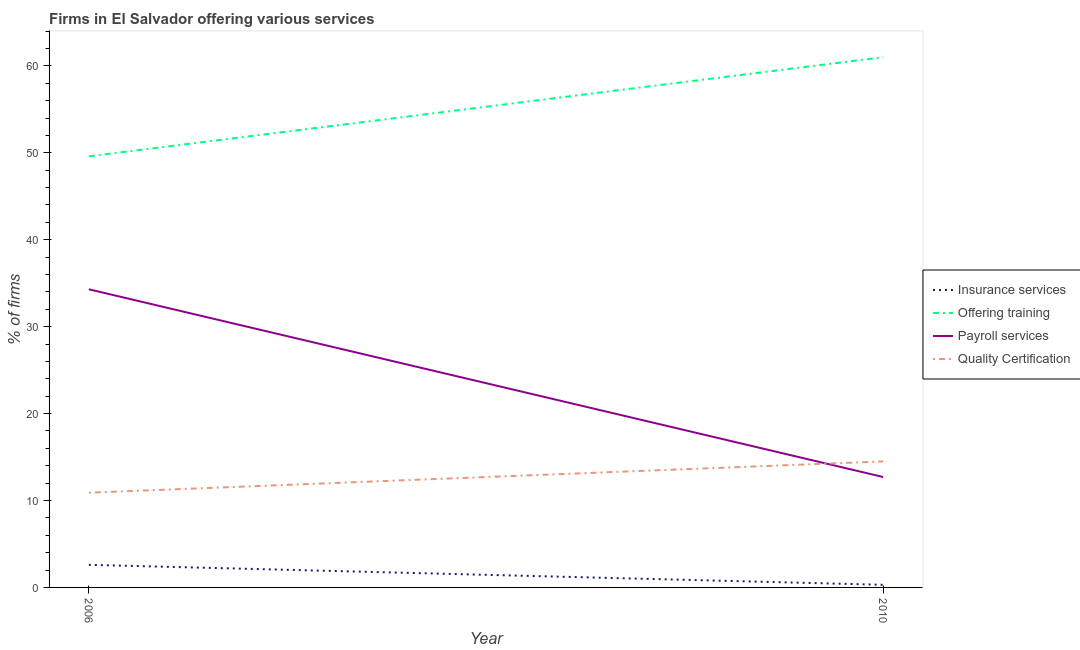How many different coloured lines are there?
Your answer should be very brief. 4. What is the percentage of firms offering insurance services in 2010?
Keep it short and to the point. 0.3. Across all years, what is the minimum percentage of firms offering insurance services?
Make the answer very short. 0.3. In which year was the percentage of firms offering quality certification minimum?
Your answer should be very brief. 2006. What is the total percentage of firms offering training in the graph?
Offer a very short reply. 110.6. What is the difference between the percentage of firms offering quality certification in 2006 and that in 2010?
Ensure brevity in your answer.  -3.6. What is the difference between the percentage of firms offering training in 2006 and the percentage of firms offering quality certification in 2010?
Your answer should be compact. 35.1. What is the average percentage of firms offering quality certification per year?
Give a very brief answer. 12.7. In the year 2006, what is the difference between the percentage of firms offering payroll services and percentage of firms offering training?
Your answer should be very brief. -15.3. In how many years, is the percentage of firms offering training greater than 12 %?
Make the answer very short. 2. What is the ratio of the percentage of firms offering quality certification in 2006 to that in 2010?
Offer a terse response. 0.75. In how many years, is the percentage of firms offering insurance services greater than the average percentage of firms offering insurance services taken over all years?
Your response must be concise. 1. Is it the case that in every year, the sum of the percentage of firms offering insurance services and percentage of firms offering training is greater than the percentage of firms offering payroll services?
Provide a short and direct response. Yes. Is the percentage of firms offering payroll services strictly greater than the percentage of firms offering insurance services over the years?
Your answer should be compact. Yes. How many lines are there?
Your answer should be compact. 4. Are the values on the major ticks of Y-axis written in scientific E-notation?
Ensure brevity in your answer.  No. Where does the legend appear in the graph?
Provide a succinct answer. Center right. What is the title of the graph?
Your answer should be compact. Firms in El Salvador offering various services . Does "Structural Policies" appear as one of the legend labels in the graph?
Your response must be concise. No. What is the label or title of the Y-axis?
Offer a very short reply. % of firms. What is the % of firms of Insurance services in 2006?
Your response must be concise. 2.6. What is the % of firms of Offering training in 2006?
Make the answer very short. 49.6. What is the % of firms of Payroll services in 2006?
Your response must be concise. 34.3. What is the % of firms in Quality Certification in 2006?
Keep it short and to the point. 10.9. What is the % of firms of Payroll services in 2010?
Your response must be concise. 12.7. What is the % of firms in Quality Certification in 2010?
Ensure brevity in your answer.  14.5. Across all years, what is the maximum % of firms in Offering training?
Offer a very short reply. 61. Across all years, what is the maximum % of firms in Payroll services?
Ensure brevity in your answer.  34.3. Across all years, what is the minimum % of firms in Insurance services?
Your answer should be very brief. 0.3. Across all years, what is the minimum % of firms of Offering training?
Keep it short and to the point. 49.6. Across all years, what is the minimum % of firms of Payroll services?
Your response must be concise. 12.7. Across all years, what is the minimum % of firms of Quality Certification?
Give a very brief answer. 10.9. What is the total % of firms of Insurance services in the graph?
Give a very brief answer. 2.9. What is the total % of firms of Offering training in the graph?
Offer a terse response. 110.6. What is the total % of firms in Payroll services in the graph?
Provide a succinct answer. 47. What is the total % of firms of Quality Certification in the graph?
Offer a terse response. 25.4. What is the difference between the % of firms in Insurance services in 2006 and that in 2010?
Your response must be concise. 2.3. What is the difference between the % of firms in Offering training in 2006 and that in 2010?
Offer a terse response. -11.4. What is the difference between the % of firms of Payroll services in 2006 and that in 2010?
Offer a very short reply. 21.6. What is the difference between the % of firms in Insurance services in 2006 and the % of firms in Offering training in 2010?
Give a very brief answer. -58.4. What is the difference between the % of firms in Insurance services in 2006 and the % of firms in Payroll services in 2010?
Offer a terse response. -10.1. What is the difference between the % of firms of Offering training in 2006 and the % of firms of Payroll services in 2010?
Your response must be concise. 36.9. What is the difference between the % of firms of Offering training in 2006 and the % of firms of Quality Certification in 2010?
Your answer should be very brief. 35.1. What is the difference between the % of firms in Payroll services in 2006 and the % of firms in Quality Certification in 2010?
Your response must be concise. 19.8. What is the average % of firms in Insurance services per year?
Provide a short and direct response. 1.45. What is the average % of firms in Offering training per year?
Your answer should be compact. 55.3. What is the average % of firms in Payroll services per year?
Your response must be concise. 23.5. In the year 2006, what is the difference between the % of firms in Insurance services and % of firms in Offering training?
Give a very brief answer. -47. In the year 2006, what is the difference between the % of firms of Insurance services and % of firms of Payroll services?
Ensure brevity in your answer.  -31.7. In the year 2006, what is the difference between the % of firms of Offering training and % of firms of Payroll services?
Your response must be concise. 15.3. In the year 2006, what is the difference between the % of firms in Offering training and % of firms in Quality Certification?
Your response must be concise. 38.7. In the year 2006, what is the difference between the % of firms in Payroll services and % of firms in Quality Certification?
Keep it short and to the point. 23.4. In the year 2010, what is the difference between the % of firms of Insurance services and % of firms of Offering training?
Make the answer very short. -60.7. In the year 2010, what is the difference between the % of firms in Insurance services and % of firms in Payroll services?
Give a very brief answer. -12.4. In the year 2010, what is the difference between the % of firms of Insurance services and % of firms of Quality Certification?
Provide a succinct answer. -14.2. In the year 2010, what is the difference between the % of firms in Offering training and % of firms in Payroll services?
Provide a short and direct response. 48.3. In the year 2010, what is the difference between the % of firms in Offering training and % of firms in Quality Certification?
Make the answer very short. 46.5. In the year 2010, what is the difference between the % of firms in Payroll services and % of firms in Quality Certification?
Give a very brief answer. -1.8. What is the ratio of the % of firms in Insurance services in 2006 to that in 2010?
Offer a very short reply. 8.67. What is the ratio of the % of firms in Offering training in 2006 to that in 2010?
Your answer should be compact. 0.81. What is the ratio of the % of firms in Payroll services in 2006 to that in 2010?
Your answer should be compact. 2.7. What is the ratio of the % of firms in Quality Certification in 2006 to that in 2010?
Your response must be concise. 0.75. What is the difference between the highest and the second highest % of firms of Insurance services?
Keep it short and to the point. 2.3. What is the difference between the highest and the second highest % of firms in Offering training?
Offer a very short reply. 11.4. What is the difference between the highest and the second highest % of firms of Payroll services?
Keep it short and to the point. 21.6. What is the difference between the highest and the second highest % of firms in Quality Certification?
Your answer should be compact. 3.6. What is the difference between the highest and the lowest % of firms in Insurance services?
Make the answer very short. 2.3. What is the difference between the highest and the lowest % of firms of Payroll services?
Offer a terse response. 21.6. 